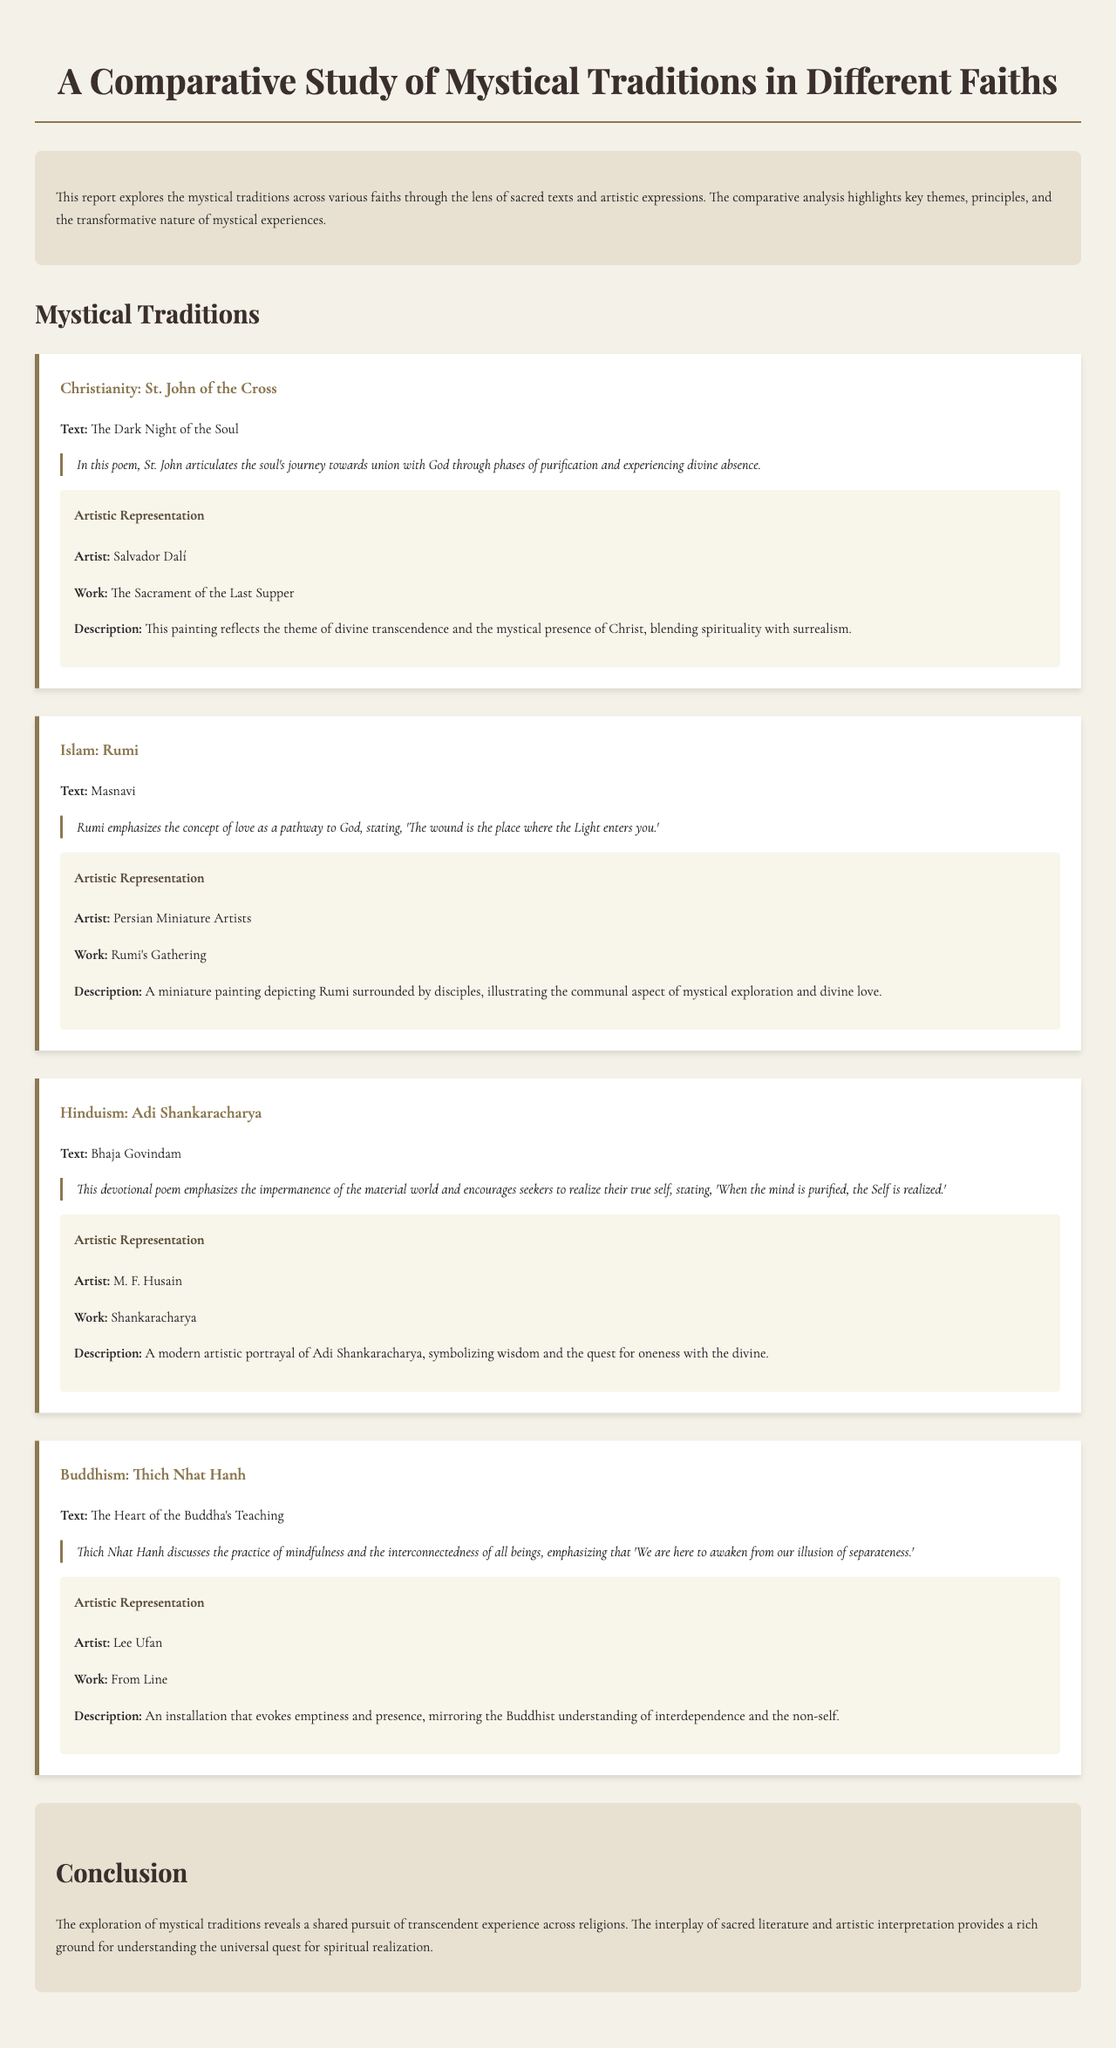What is the focus of the report? The report explores the mystical traditions across various faiths through the lens of sacred texts and artistic expressions.
Answer: Mystical traditions across various faiths Who is the artist of "The Sacrament of the Last Supper"? The report lists Salvador Dalí as the artist of this work.
Answer: Salvador Dalí Which text is associated with Rumi? The text highlighted in the report for Rumi is the Masnavi.
Answer: Masnavi What is the central theme discussed by Thich Nhat Hanh? Thich Nhat Hanh emphasizes the practice of mindfulness and the interconnectedness of all beings.
Answer: Mindfulness and interconnectedness How is divine love depicted in Rumi's context? Rumi emphasizes love as a pathway to God, conveying this through the quote about wounds and Light.
Answer: "The wound is the place where the Light enters you." What is the artistic representation for Adi Shankaracharya? The modern artistic portrayal is by M. F. Husain.
Answer: M. F. Husain What does the conclusion of the report suggest? The conclusion suggests that there is a shared pursuit of transcendent experience across religions.
Answer: Shared pursuit of transcendent experience Which divine concept is presented by St. John of the Cross? The poem discusses the soul's journey towards union with God.
Answer: Union with God 